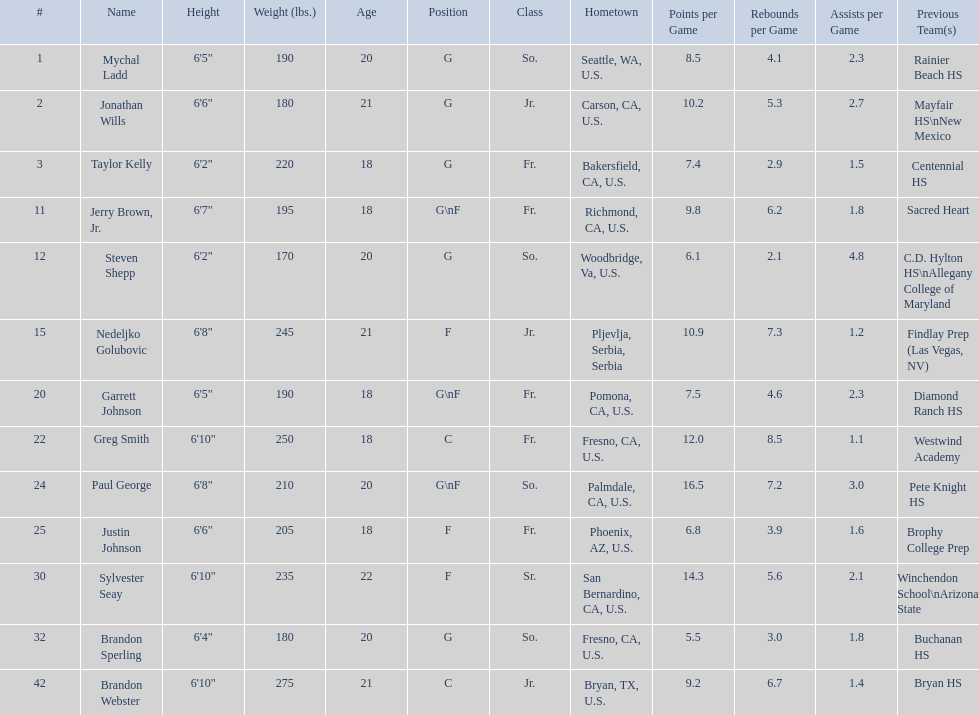Which positions are so.? G, G, G\nF, G. Which weights are g 190, 170, 180. What height is under 6 3' 6'2". What is the name Steven Shepp. 